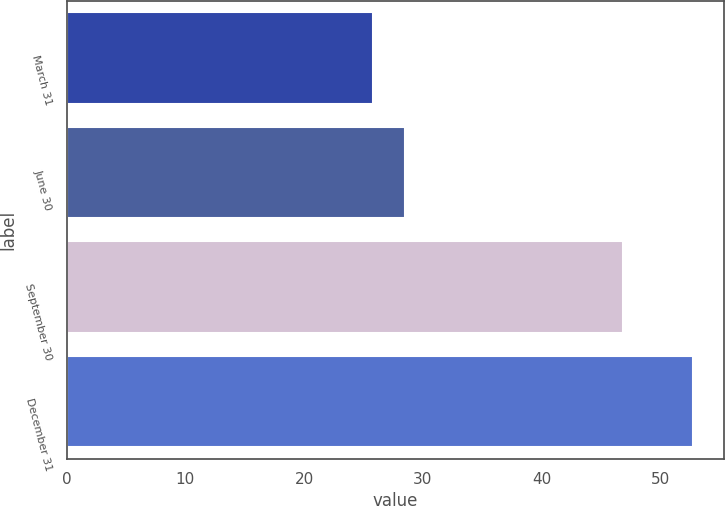Convert chart. <chart><loc_0><loc_0><loc_500><loc_500><bar_chart><fcel>March 31<fcel>June 30<fcel>September 30<fcel>December 31<nl><fcel>25.83<fcel>28.52<fcel>46.81<fcel>52.74<nl></chart> 